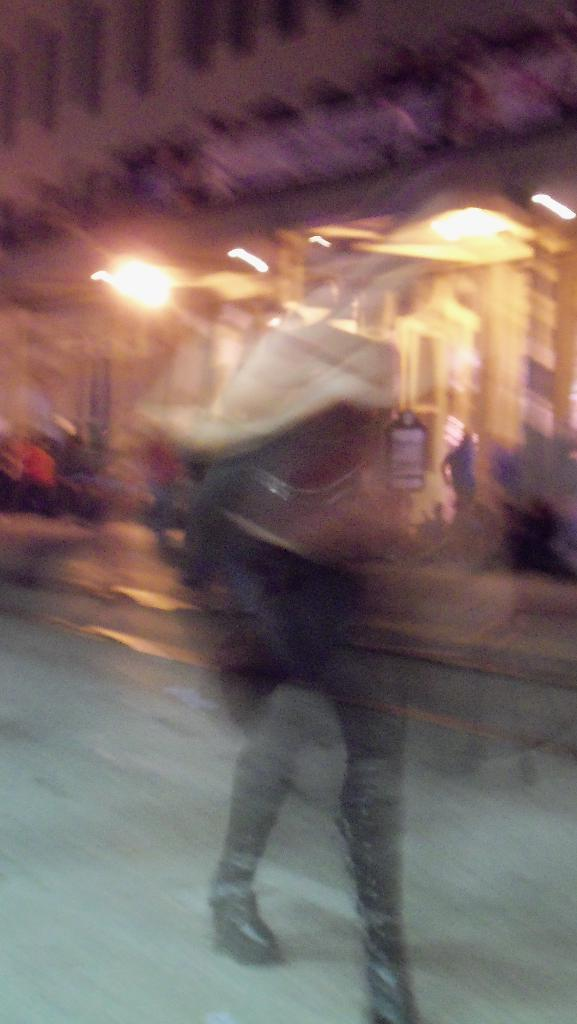What is located in the foreground of the image? There is a person in the foreground of the image. What can be seen in the background of the image? There is a building, lights, people, trees, and a road visible in the background of the image. What type of fruit is being rewarded to the plant in the image? There is no fruit or plant present in the image, so it is not possible to answer that question. 